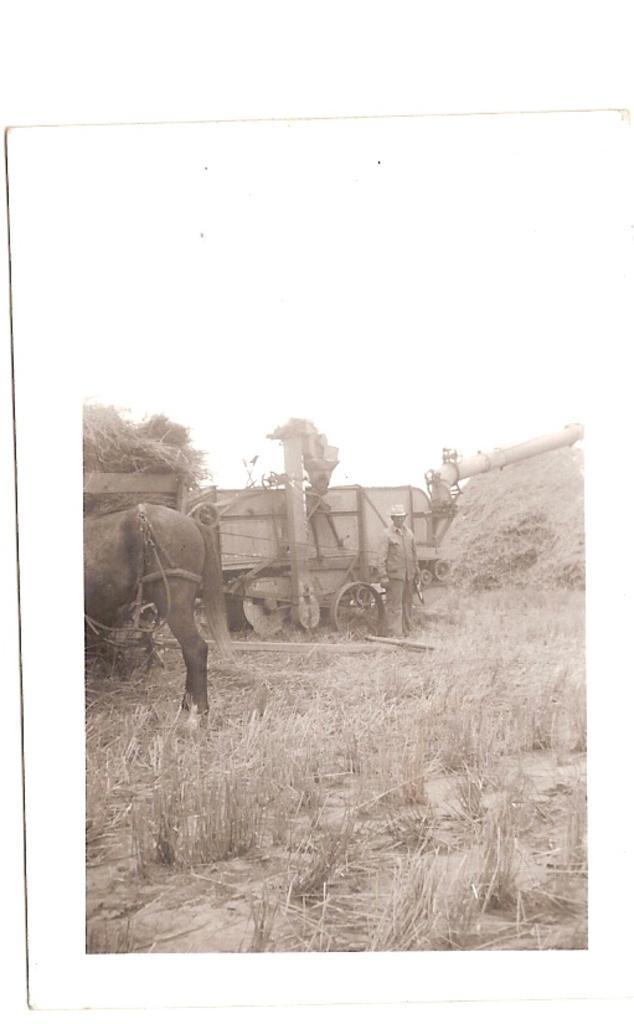How would you summarize this image in a sentence or two? This is a black and white image. At the bottom of the image I can see the grass. To the left side there is an animal. Beside that I can see a vehicle and a person is standing. On the top of the image I can see the sky. 